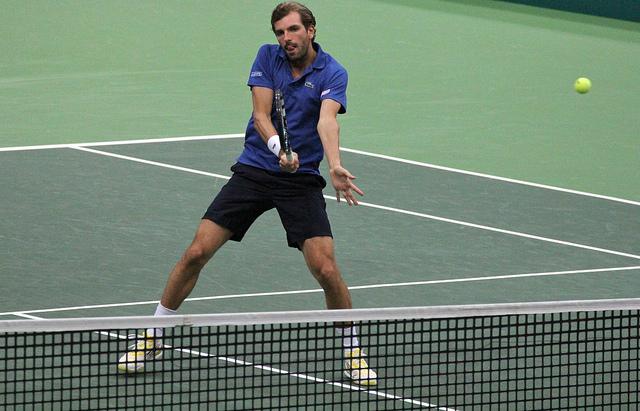Did the player just miss the ball?
Quick response, please. No. What sport is being played?
Be succinct. Tennis. What color are the shorts?
Write a very short answer. Black. Is the man running toward the ball?
Short answer required. No. Is the man's hair curly or straight?
Quick response, please. Straight. 